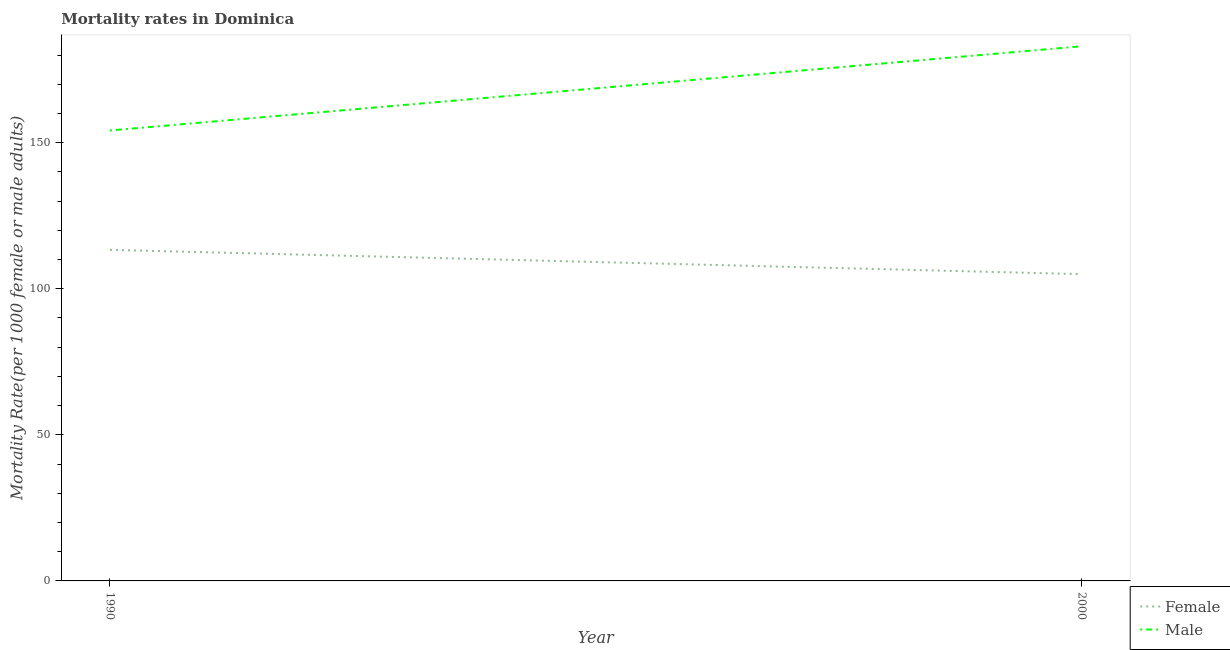What is the male mortality rate in 1990?
Offer a very short reply. 154.18. Across all years, what is the maximum female mortality rate?
Offer a very short reply. 113.32. Across all years, what is the minimum female mortality rate?
Your answer should be very brief. 105. What is the total female mortality rate in the graph?
Keep it short and to the point. 218.32. What is the difference between the female mortality rate in 1990 and that in 2000?
Provide a succinct answer. 8.32. What is the difference between the male mortality rate in 2000 and the female mortality rate in 1990?
Provide a succinct answer. 69.68. What is the average female mortality rate per year?
Make the answer very short. 109.16. In the year 2000, what is the difference between the female mortality rate and male mortality rate?
Your answer should be compact. -78. In how many years, is the female mortality rate greater than 100?
Offer a very short reply. 2. What is the ratio of the male mortality rate in 1990 to that in 2000?
Your response must be concise. 0.84. Is the female mortality rate in 1990 less than that in 2000?
Ensure brevity in your answer.  No. In how many years, is the female mortality rate greater than the average female mortality rate taken over all years?
Ensure brevity in your answer.  1. Is the male mortality rate strictly greater than the female mortality rate over the years?
Provide a short and direct response. Yes. How many years are there in the graph?
Make the answer very short. 2. What is the difference between two consecutive major ticks on the Y-axis?
Keep it short and to the point. 50. Are the values on the major ticks of Y-axis written in scientific E-notation?
Give a very brief answer. No. Does the graph contain any zero values?
Offer a very short reply. No. Does the graph contain grids?
Keep it short and to the point. No. How many legend labels are there?
Ensure brevity in your answer.  2. How are the legend labels stacked?
Provide a succinct answer. Vertical. What is the title of the graph?
Give a very brief answer. Mortality rates in Dominica. Does "ODA received" appear as one of the legend labels in the graph?
Your response must be concise. No. What is the label or title of the Y-axis?
Make the answer very short. Mortality Rate(per 1000 female or male adults). What is the Mortality Rate(per 1000 female or male adults) of Female in 1990?
Provide a short and direct response. 113.32. What is the Mortality Rate(per 1000 female or male adults) in Male in 1990?
Your answer should be very brief. 154.18. What is the Mortality Rate(per 1000 female or male adults) of Female in 2000?
Your response must be concise. 105. What is the Mortality Rate(per 1000 female or male adults) of Male in 2000?
Ensure brevity in your answer.  183. Across all years, what is the maximum Mortality Rate(per 1000 female or male adults) of Female?
Give a very brief answer. 113.32. Across all years, what is the maximum Mortality Rate(per 1000 female or male adults) in Male?
Provide a succinct answer. 183. Across all years, what is the minimum Mortality Rate(per 1000 female or male adults) of Female?
Provide a short and direct response. 105. Across all years, what is the minimum Mortality Rate(per 1000 female or male adults) of Male?
Your answer should be very brief. 154.18. What is the total Mortality Rate(per 1000 female or male adults) of Female in the graph?
Your response must be concise. 218.32. What is the total Mortality Rate(per 1000 female or male adults) in Male in the graph?
Provide a short and direct response. 337.18. What is the difference between the Mortality Rate(per 1000 female or male adults) in Female in 1990 and that in 2000?
Your response must be concise. 8.32. What is the difference between the Mortality Rate(per 1000 female or male adults) in Male in 1990 and that in 2000?
Keep it short and to the point. -28.82. What is the difference between the Mortality Rate(per 1000 female or male adults) of Female in 1990 and the Mortality Rate(per 1000 female or male adults) of Male in 2000?
Your response must be concise. -69.68. What is the average Mortality Rate(per 1000 female or male adults) in Female per year?
Your answer should be very brief. 109.16. What is the average Mortality Rate(per 1000 female or male adults) in Male per year?
Offer a very short reply. 168.59. In the year 1990, what is the difference between the Mortality Rate(per 1000 female or male adults) of Female and Mortality Rate(per 1000 female or male adults) of Male?
Provide a succinct answer. -40.86. In the year 2000, what is the difference between the Mortality Rate(per 1000 female or male adults) in Female and Mortality Rate(per 1000 female or male adults) in Male?
Keep it short and to the point. -78. What is the ratio of the Mortality Rate(per 1000 female or male adults) in Female in 1990 to that in 2000?
Your answer should be very brief. 1.08. What is the ratio of the Mortality Rate(per 1000 female or male adults) of Male in 1990 to that in 2000?
Offer a terse response. 0.84. What is the difference between the highest and the second highest Mortality Rate(per 1000 female or male adults) of Female?
Provide a short and direct response. 8.32. What is the difference between the highest and the second highest Mortality Rate(per 1000 female or male adults) of Male?
Provide a succinct answer. 28.82. What is the difference between the highest and the lowest Mortality Rate(per 1000 female or male adults) of Female?
Keep it short and to the point. 8.32. What is the difference between the highest and the lowest Mortality Rate(per 1000 female or male adults) of Male?
Your answer should be very brief. 28.82. 